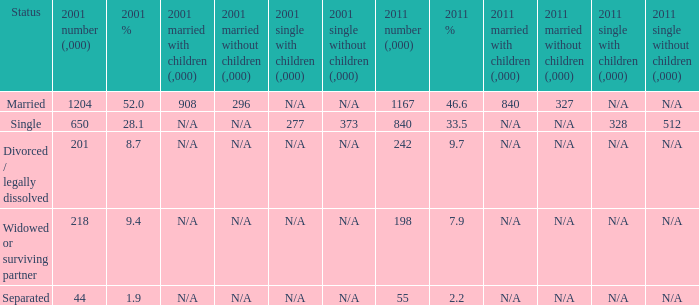Would you be able to parse every entry in this table? {'header': ['Status', '2001 number (,000)', '2001 %', '2001 married with children (,000)', '2001 married without children (,000)', '2001 single with children (,000)', '2001 single without children (,000)', '2011 number (,000)', '2011 %', '2011 married with children (,000)', '2011 married without children (,000)', '2011 single with children (,000)', '2011 single without children (,000)'], 'rows': [['Married', '1204', '52.0', '908', '296', 'N/A', 'N/A', '1167', '46.6', '840', '327', 'N/A', 'N/A'], ['Single', '650', '28.1', 'N/A', 'N/A', '277', '373', '840', '33.5', 'N/A', 'N/A', '328', '512'], ['Divorced / legally dissolved', '201', '8.7', 'N/A', 'N/A', 'N/A', 'N/A', '242', '9.7', 'N/A', 'N/A', 'N/A', 'N/A'], ['Widowed or surviving partner', '218', '9.4', 'N/A', 'N/A', 'N/A', 'N/A', '198', '7.9', 'N/A', 'N/A', 'N/A', 'N/A'], ['Separated', '44', '1.9', 'N/A', 'N/A', 'N/A', 'N/A', '55', '2.2', 'N/A', 'N/A', 'N/A', 'N/A']]} What is the 2001 % for the status widowed or surviving partner? 9.4. 